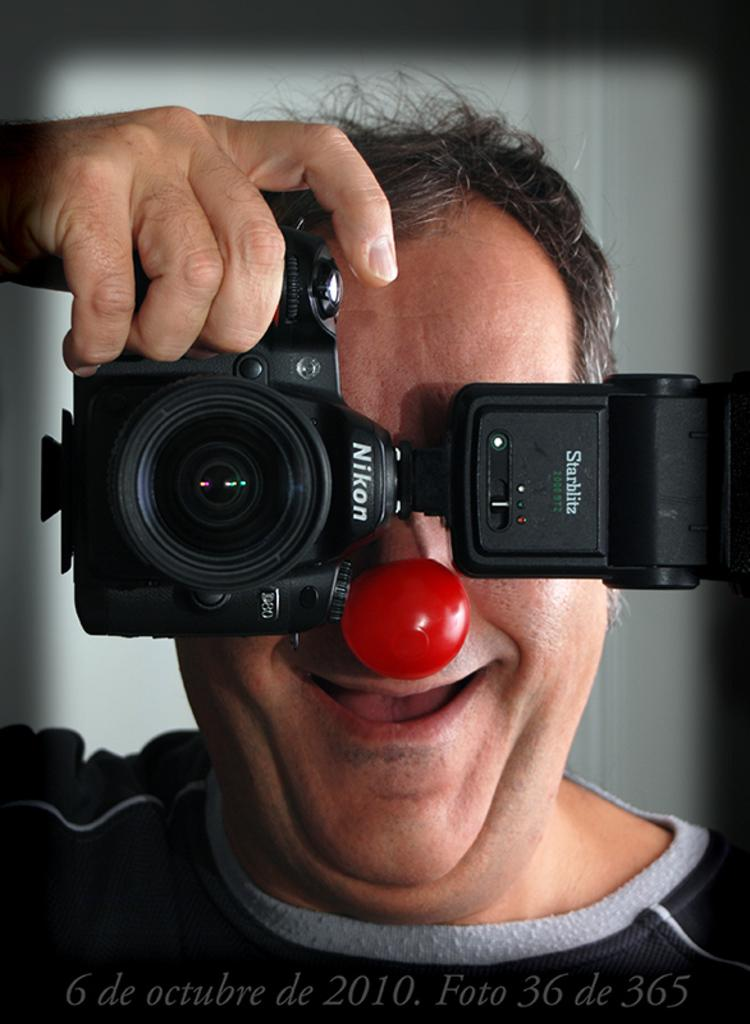Who is the main subject in the image? There is a man in the image. What is the man holding in the image? The man is holding a camera. What is the man's facial expression in the image? The man is smiling. What can be seen at the bottom of the image? There is text at the bottom of the image. What is visible in the background of the image? There is a wall visible in the background of the image. What type of amusement can be seen in the image? There is no amusement present in the image; it features a man holding a camera and smiling. What direction is the zephyr blowing in the image? There is no mention of a zephyr or any wind in the image; it is a still photograph. 